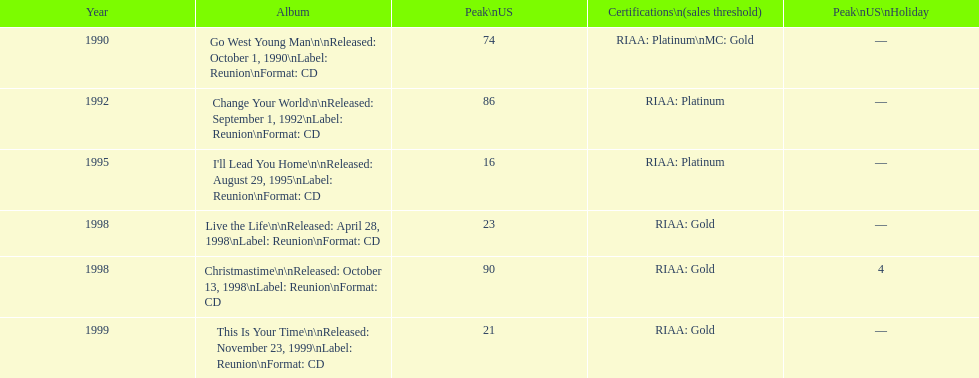How many songs are listed from 1998? 2. Would you mind parsing the complete table? {'header': ['Year', 'Album', 'Peak\\nUS', 'Certifications\\n(sales threshold)', 'Peak\\nUS\\nHoliday'], 'rows': [['1990', 'Go West Young Man\\n\\nReleased: October 1, 1990\\nLabel: Reunion\\nFormat: CD', '74', 'RIAA: Platinum\\nMC: Gold', '—'], ['1992', 'Change Your World\\n\\nReleased: September 1, 1992\\nLabel: Reunion\\nFormat: CD', '86', 'RIAA: Platinum', '—'], ['1995', "I'll Lead You Home\\n\\nReleased: August 29, 1995\\nLabel: Reunion\\nFormat: CD", '16', 'RIAA: Platinum', '—'], ['1998', 'Live the Life\\n\\nReleased: April 28, 1998\\nLabel: Reunion\\nFormat: CD', '23', 'RIAA: Gold', '—'], ['1998', 'Christmastime\\n\\nReleased: October 13, 1998\\nLabel: Reunion\\nFormat: CD', '90', 'RIAA: Gold', '4'], ['1999', 'This Is Your Time\\n\\nReleased: November 23, 1999\\nLabel: Reunion\\nFormat: CD', '21', 'RIAA: Gold', '—']]} 